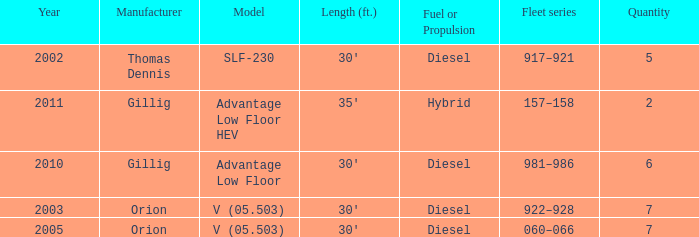Identify the total amount of units for the pre-2011 slf-230 model. 5.0. 